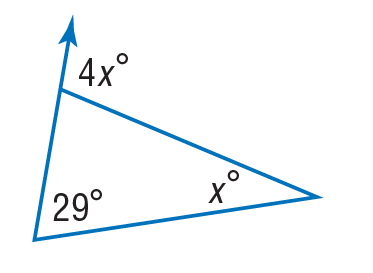Question: Find x to the nearest tenth.
Choices:
A. 5.8
B. 7.25
C. 9.67
D. 29
Answer with the letter. Answer: C 